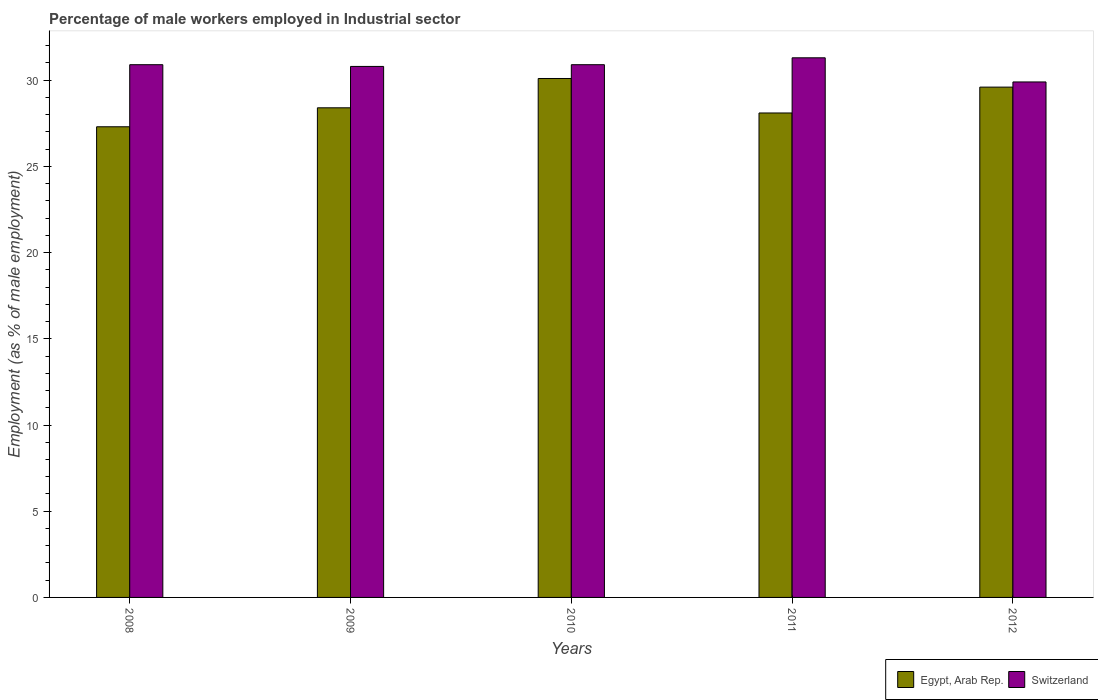How many different coloured bars are there?
Provide a succinct answer. 2. How many bars are there on the 5th tick from the left?
Provide a succinct answer. 2. What is the label of the 4th group of bars from the left?
Offer a very short reply. 2011. What is the percentage of male workers employed in Industrial sector in Egypt, Arab Rep. in 2009?
Your response must be concise. 28.4. Across all years, what is the maximum percentage of male workers employed in Industrial sector in Switzerland?
Your answer should be compact. 31.3. Across all years, what is the minimum percentage of male workers employed in Industrial sector in Egypt, Arab Rep.?
Offer a very short reply. 27.3. In which year was the percentage of male workers employed in Industrial sector in Egypt, Arab Rep. maximum?
Keep it short and to the point. 2010. What is the total percentage of male workers employed in Industrial sector in Egypt, Arab Rep. in the graph?
Keep it short and to the point. 143.5. What is the difference between the percentage of male workers employed in Industrial sector in Egypt, Arab Rep. in 2009 and that in 2010?
Give a very brief answer. -1.7. What is the average percentage of male workers employed in Industrial sector in Switzerland per year?
Offer a very short reply. 30.76. In the year 2009, what is the difference between the percentage of male workers employed in Industrial sector in Egypt, Arab Rep. and percentage of male workers employed in Industrial sector in Switzerland?
Give a very brief answer. -2.4. What is the ratio of the percentage of male workers employed in Industrial sector in Egypt, Arab Rep. in 2009 to that in 2012?
Offer a terse response. 0.96. What is the difference between the highest and the second highest percentage of male workers employed in Industrial sector in Switzerland?
Provide a short and direct response. 0.4. What is the difference between the highest and the lowest percentage of male workers employed in Industrial sector in Switzerland?
Keep it short and to the point. 1.4. Is the sum of the percentage of male workers employed in Industrial sector in Egypt, Arab Rep. in 2008 and 2009 greater than the maximum percentage of male workers employed in Industrial sector in Switzerland across all years?
Your response must be concise. Yes. What does the 1st bar from the left in 2008 represents?
Your response must be concise. Egypt, Arab Rep. What does the 1st bar from the right in 2011 represents?
Make the answer very short. Switzerland. How many years are there in the graph?
Make the answer very short. 5. What is the difference between two consecutive major ticks on the Y-axis?
Your response must be concise. 5. Are the values on the major ticks of Y-axis written in scientific E-notation?
Make the answer very short. No. Does the graph contain grids?
Your answer should be compact. No. What is the title of the graph?
Give a very brief answer. Percentage of male workers employed in Industrial sector. Does "Denmark" appear as one of the legend labels in the graph?
Your answer should be compact. No. What is the label or title of the X-axis?
Your answer should be very brief. Years. What is the label or title of the Y-axis?
Offer a very short reply. Employment (as % of male employment). What is the Employment (as % of male employment) in Egypt, Arab Rep. in 2008?
Your answer should be compact. 27.3. What is the Employment (as % of male employment) in Switzerland in 2008?
Your response must be concise. 30.9. What is the Employment (as % of male employment) in Egypt, Arab Rep. in 2009?
Provide a succinct answer. 28.4. What is the Employment (as % of male employment) in Switzerland in 2009?
Keep it short and to the point. 30.8. What is the Employment (as % of male employment) of Egypt, Arab Rep. in 2010?
Provide a succinct answer. 30.1. What is the Employment (as % of male employment) in Switzerland in 2010?
Give a very brief answer. 30.9. What is the Employment (as % of male employment) of Egypt, Arab Rep. in 2011?
Keep it short and to the point. 28.1. What is the Employment (as % of male employment) of Switzerland in 2011?
Give a very brief answer. 31.3. What is the Employment (as % of male employment) in Egypt, Arab Rep. in 2012?
Offer a very short reply. 29.6. What is the Employment (as % of male employment) in Switzerland in 2012?
Your answer should be compact. 29.9. Across all years, what is the maximum Employment (as % of male employment) in Egypt, Arab Rep.?
Ensure brevity in your answer.  30.1. Across all years, what is the maximum Employment (as % of male employment) in Switzerland?
Your response must be concise. 31.3. Across all years, what is the minimum Employment (as % of male employment) of Egypt, Arab Rep.?
Your answer should be compact. 27.3. Across all years, what is the minimum Employment (as % of male employment) in Switzerland?
Provide a short and direct response. 29.9. What is the total Employment (as % of male employment) in Egypt, Arab Rep. in the graph?
Your response must be concise. 143.5. What is the total Employment (as % of male employment) of Switzerland in the graph?
Give a very brief answer. 153.8. What is the difference between the Employment (as % of male employment) of Egypt, Arab Rep. in 2008 and that in 2012?
Provide a succinct answer. -2.3. What is the difference between the Employment (as % of male employment) in Switzerland in 2008 and that in 2012?
Offer a very short reply. 1. What is the difference between the Employment (as % of male employment) of Egypt, Arab Rep. in 2009 and that in 2010?
Your response must be concise. -1.7. What is the difference between the Employment (as % of male employment) of Egypt, Arab Rep. in 2009 and that in 2011?
Make the answer very short. 0.3. What is the difference between the Employment (as % of male employment) of Switzerland in 2009 and that in 2011?
Your response must be concise. -0.5. What is the difference between the Employment (as % of male employment) in Egypt, Arab Rep. in 2009 and that in 2012?
Provide a short and direct response. -1.2. What is the difference between the Employment (as % of male employment) of Switzerland in 2009 and that in 2012?
Your response must be concise. 0.9. What is the difference between the Employment (as % of male employment) of Egypt, Arab Rep. in 2010 and that in 2011?
Keep it short and to the point. 2. What is the difference between the Employment (as % of male employment) of Egypt, Arab Rep. in 2010 and that in 2012?
Offer a terse response. 0.5. What is the difference between the Employment (as % of male employment) in Egypt, Arab Rep. in 2011 and that in 2012?
Ensure brevity in your answer.  -1.5. What is the difference between the Employment (as % of male employment) of Egypt, Arab Rep. in 2008 and the Employment (as % of male employment) of Switzerland in 2009?
Your answer should be compact. -3.5. What is the difference between the Employment (as % of male employment) of Egypt, Arab Rep. in 2008 and the Employment (as % of male employment) of Switzerland in 2012?
Keep it short and to the point. -2.6. What is the difference between the Employment (as % of male employment) in Egypt, Arab Rep. in 2009 and the Employment (as % of male employment) in Switzerland in 2012?
Offer a very short reply. -1.5. What is the average Employment (as % of male employment) of Egypt, Arab Rep. per year?
Your answer should be compact. 28.7. What is the average Employment (as % of male employment) in Switzerland per year?
Offer a very short reply. 30.76. In the year 2009, what is the difference between the Employment (as % of male employment) of Egypt, Arab Rep. and Employment (as % of male employment) of Switzerland?
Make the answer very short. -2.4. In the year 2010, what is the difference between the Employment (as % of male employment) of Egypt, Arab Rep. and Employment (as % of male employment) of Switzerland?
Ensure brevity in your answer.  -0.8. What is the ratio of the Employment (as % of male employment) in Egypt, Arab Rep. in 2008 to that in 2009?
Give a very brief answer. 0.96. What is the ratio of the Employment (as % of male employment) of Egypt, Arab Rep. in 2008 to that in 2010?
Your response must be concise. 0.91. What is the ratio of the Employment (as % of male employment) in Switzerland in 2008 to that in 2010?
Ensure brevity in your answer.  1. What is the ratio of the Employment (as % of male employment) of Egypt, Arab Rep. in 2008 to that in 2011?
Your response must be concise. 0.97. What is the ratio of the Employment (as % of male employment) of Switzerland in 2008 to that in 2011?
Provide a short and direct response. 0.99. What is the ratio of the Employment (as % of male employment) in Egypt, Arab Rep. in 2008 to that in 2012?
Offer a terse response. 0.92. What is the ratio of the Employment (as % of male employment) of Switzerland in 2008 to that in 2012?
Offer a terse response. 1.03. What is the ratio of the Employment (as % of male employment) of Egypt, Arab Rep. in 2009 to that in 2010?
Offer a terse response. 0.94. What is the ratio of the Employment (as % of male employment) of Egypt, Arab Rep. in 2009 to that in 2011?
Provide a succinct answer. 1.01. What is the ratio of the Employment (as % of male employment) in Egypt, Arab Rep. in 2009 to that in 2012?
Provide a succinct answer. 0.96. What is the ratio of the Employment (as % of male employment) of Switzerland in 2009 to that in 2012?
Ensure brevity in your answer.  1.03. What is the ratio of the Employment (as % of male employment) of Egypt, Arab Rep. in 2010 to that in 2011?
Your answer should be compact. 1.07. What is the ratio of the Employment (as % of male employment) of Switzerland in 2010 to that in 2011?
Offer a very short reply. 0.99. What is the ratio of the Employment (as % of male employment) in Egypt, Arab Rep. in 2010 to that in 2012?
Keep it short and to the point. 1.02. What is the ratio of the Employment (as % of male employment) of Switzerland in 2010 to that in 2012?
Your response must be concise. 1.03. What is the ratio of the Employment (as % of male employment) in Egypt, Arab Rep. in 2011 to that in 2012?
Give a very brief answer. 0.95. What is the ratio of the Employment (as % of male employment) in Switzerland in 2011 to that in 2012?
Offer a terse response. 1.05. What is the difference between the highest and the lowest Employment (as % of male employment) of Egypt, Arab Rep.?
Make the answer very short. 2.8. 